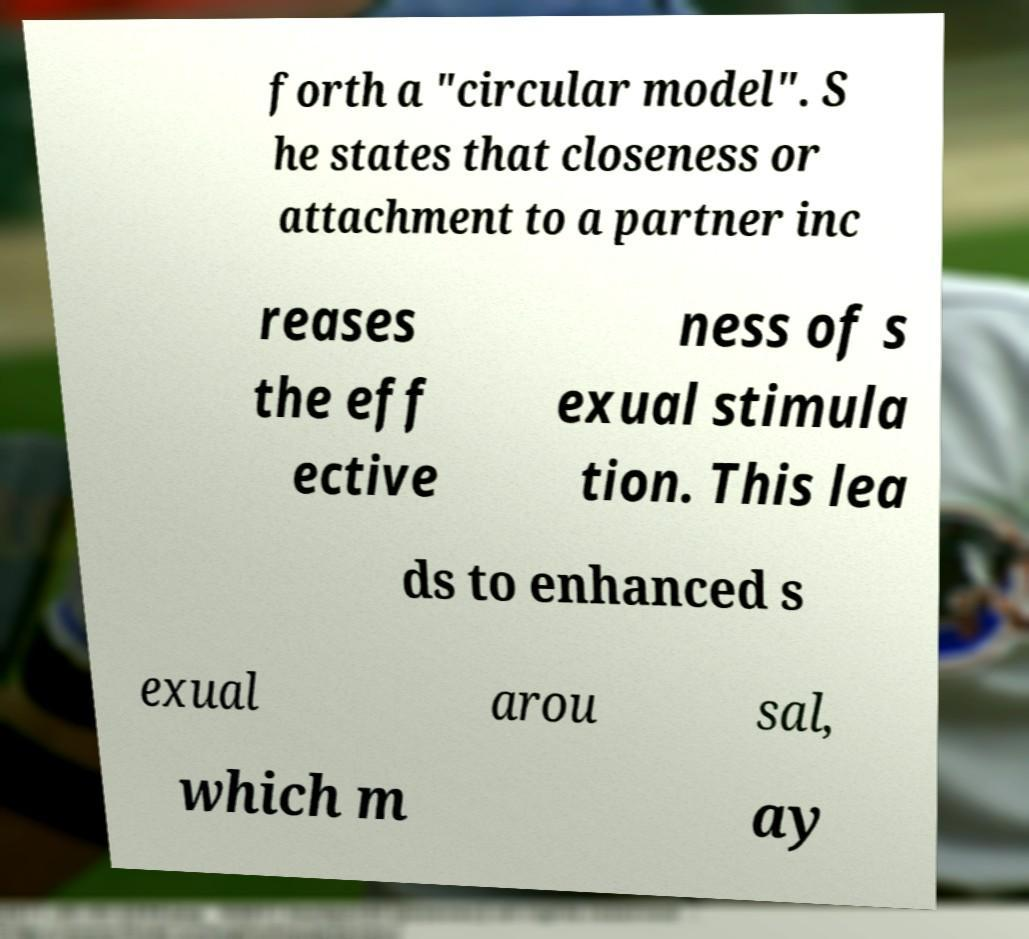Please read and relay the text visible in this image. What does it say? forth a "circular model". S he states that closeness or attachment to a partner inc reases the eff ective ness of s exual stimula tion. This lea ds to enhanced s exual arou sal, which m ay 